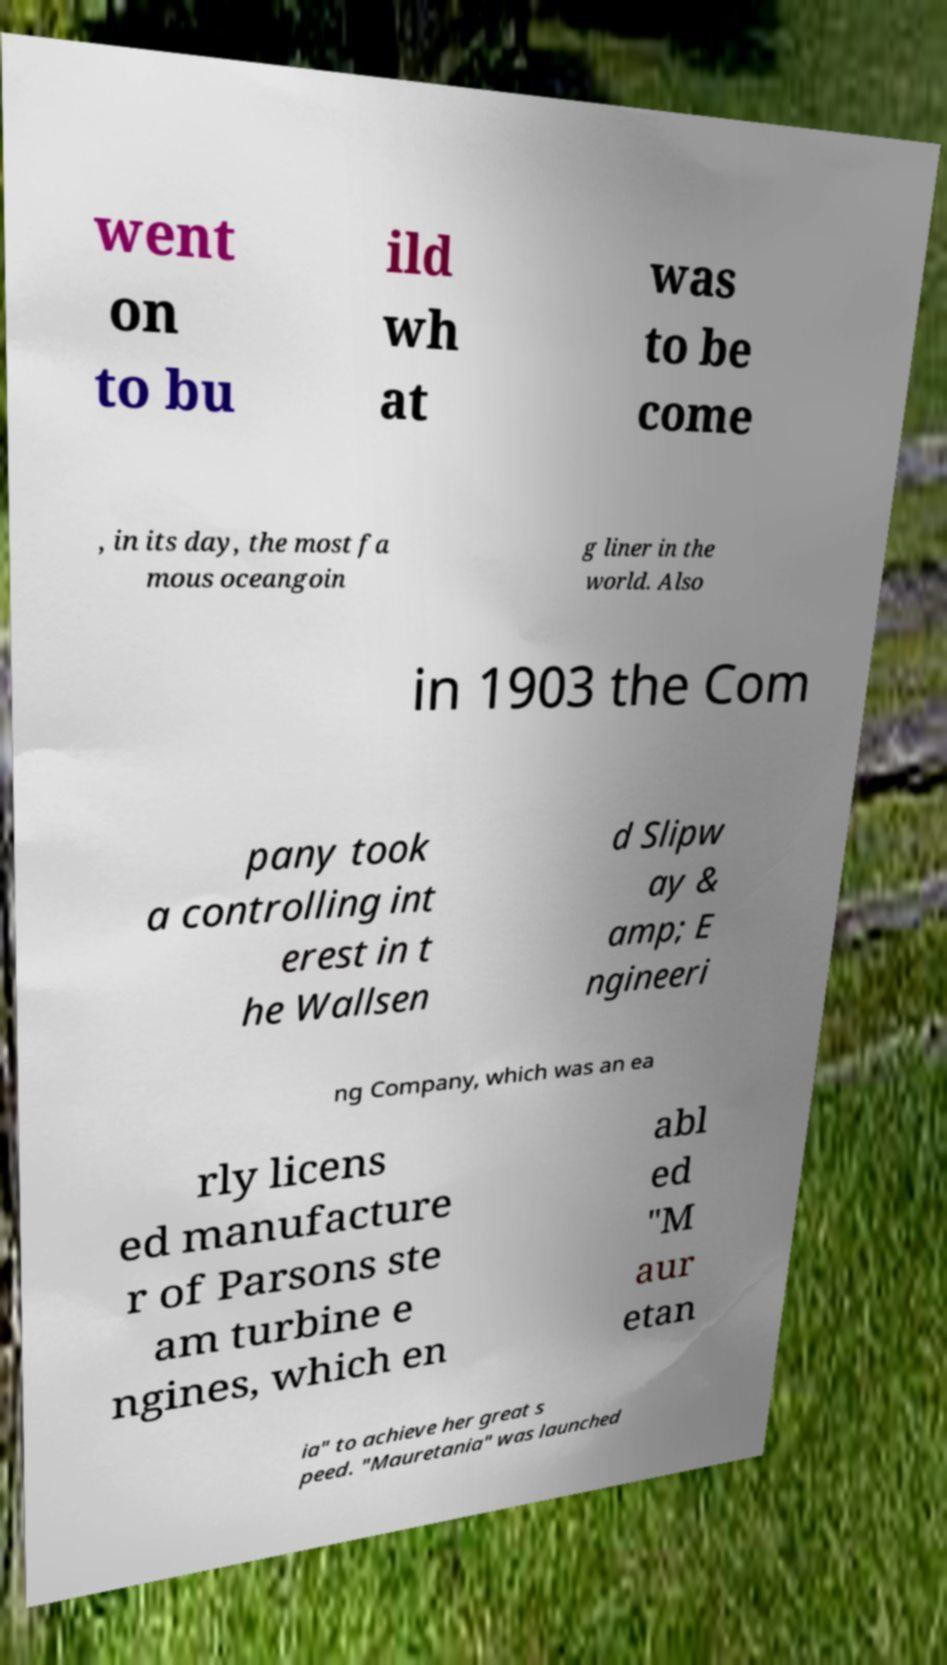Please read and relay the text visible in this image. What does it say? went on to bu ild wh at was to be come , in its day, the most fa mous oceangoin g liner in the world. Also in 1903 the Com pany took a controlling int erest in t he Wallsen d Slipw ay & amp; E ngineeri ng Company, which was an ea rly licens ed manufacture r of Parsons ste am turbine e ngines, which en abl ed "M aur etan ia" to achieve her great s peed. "Mauretania" was launched 